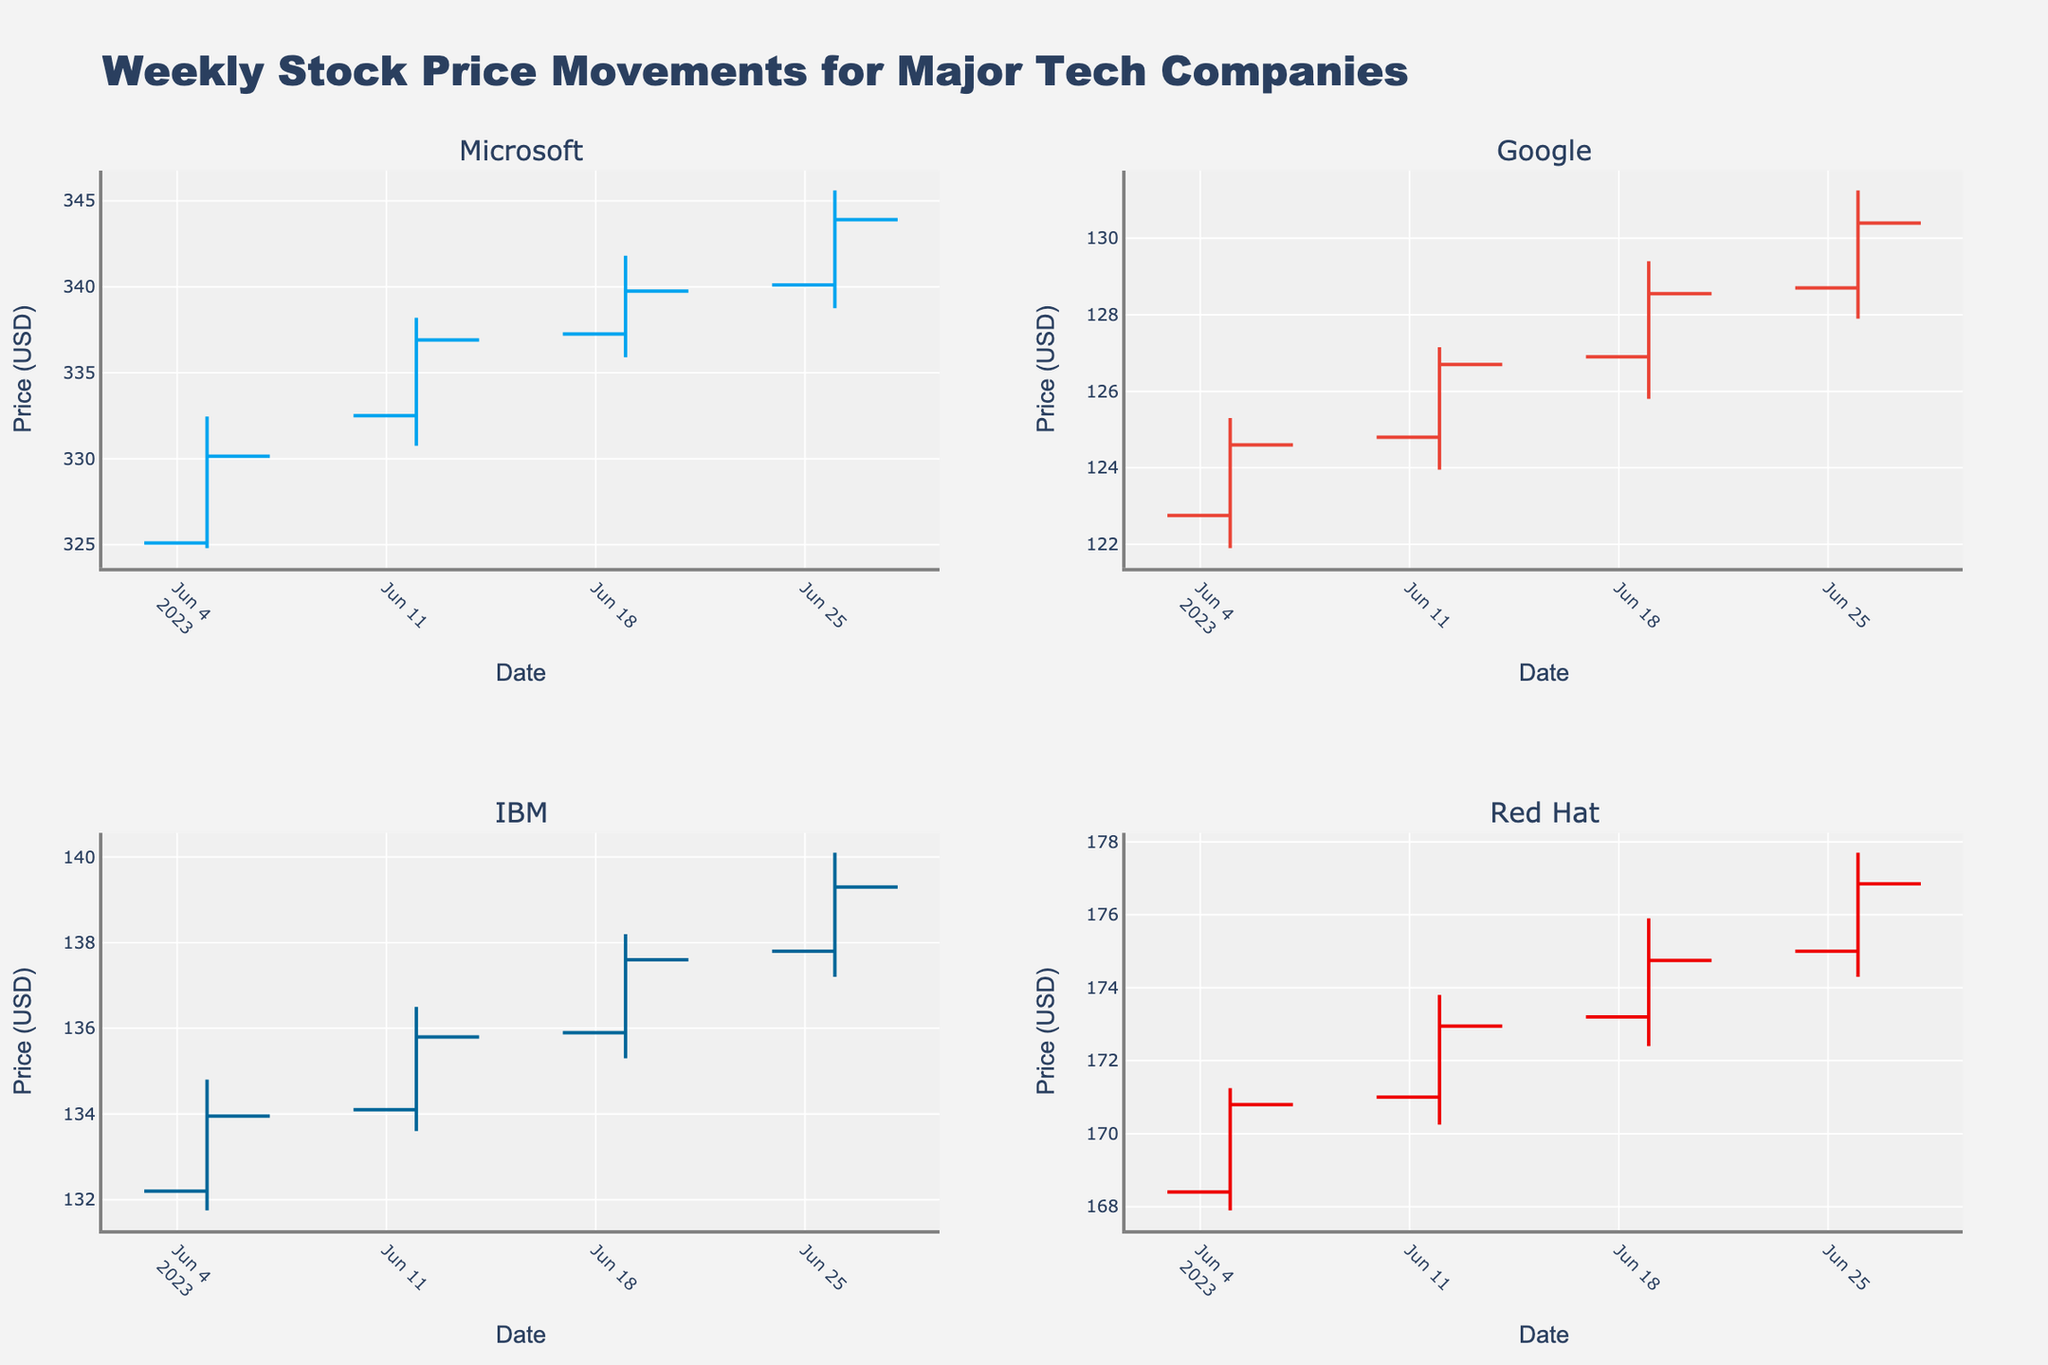What is the title of the figure? The figure's title is typically displayed at the top and summarises the main content of the chart. For this figure, it states "Weekly Stock Price Movements for Major Tech Companies".
Answer: Weekly Stock Price Movements for Major Tech Companies How many companies are displayed in the subplots? There are typically four subplots arranged in a grid format, each representing a company involved in the chart. From the subplot titles, we see four companies displayed.
Answer: Four What color represents Microsoft's stock movements? By looking at Microsoft's subplot, the line colors for increasing and decreasing movements are observed. In Microsoft's case, the increasing line color is blue, denoted by the color specific to Microsoft.
Answer: Blue Which company had the highest closing price and what was that price? By examining each subplot and comparing the maximum closing prices indicated in the dataset, you can see that Microsoft had the highest closing price at $343.90 on June 26, 2023.
Answer: Microsoft, $343.90 Between which weeks did Red Hat see the greatest increase in closing price? Checking the closing prices for each week in Red Hat's subplot, we find a 2.15 increase from $170.80 on June 5 to $172.95 on June 12. The other intervals show smaller increases.
Answer: June 5 to June 12 What was Google's highest high price in the dataset? Within Google’s subplot, and given the data points, the highest value in the 'High' column is observed at $131.25 on June 26, 2023.
Answer: $131.25 Was there any week where IBM's closing price was lower than its opening price? Comparing the 'Open' and 'Close' prices for each week in IBM's subplot, we find no week where the closing price is less than the opening price. IBM's closing prices are consistently higher.
Answer: No How much did the closing price of Microsoft change from June 5 to June 26? Microsoft's closing price on June 5 was $330.15, and on June 26 it was $343.90. The change is $343.90 - $330.15 = $13.75.
Answer: $13.75 Which company's stock had the least volatility (Smallest range of high and low prices) on June 19? By calculating the range (High minus Low) for each company on June 19, we find that Google had the smallest range: $129.40 - $125.80 = $3.60.
Answer: Google What was the average closing price of IBM over the four weeks? IBM's closing prices are $133.95, $135.80, $137.60, and $139.30. The average is calculated as (133.95 + 135.80 + 137.60 + 139.30) / 4.
Answer: $136.66 